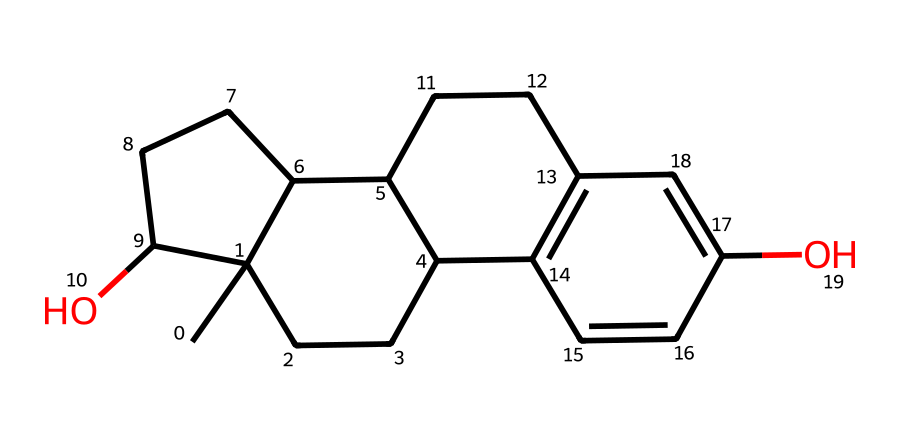How many rings are present in the chemical structure? By examining the SMILES representation, we can identify multiple cyclic structures. In this case, there are four rings present, which can be confirmed by visualizing or interpreting the cyclic patterns in the chemical structure.
Answer: four What functional groups can be identified in this compound? In the SMILES representation, the presence of "O" indicates hydroxyl groups (-OH), which signifies that there are two phenolic hydroxyl groups present in the structure.
Answer: hydroxyl groups What is the molecular formula of this compound? Analyzing the number of carbon (C), hydrogen (H), and oxygen (O) atoms present in the structure, we can summarize that there are 18 carbons, 24 hydrogens, and 2 oxygens, which leads to the molecular formula C18H24O2.
Answer: C18H24O2 What is the name of this hormone? This chemical structure corresponds to a well-known hormone involved in female development, and by connecting the structure to its biological function, we identify it as estrogen.
Answer: estrogen How does the presence of hydroxyl groups affect the properties of this compound? The hydroxyl groups contribute to the polarity of the molecule, affecting its solubility in water and influencing its biological activity as a hormone, promoting estrogen-related effects such as development and reproductive health.
Answer: increases polarity 